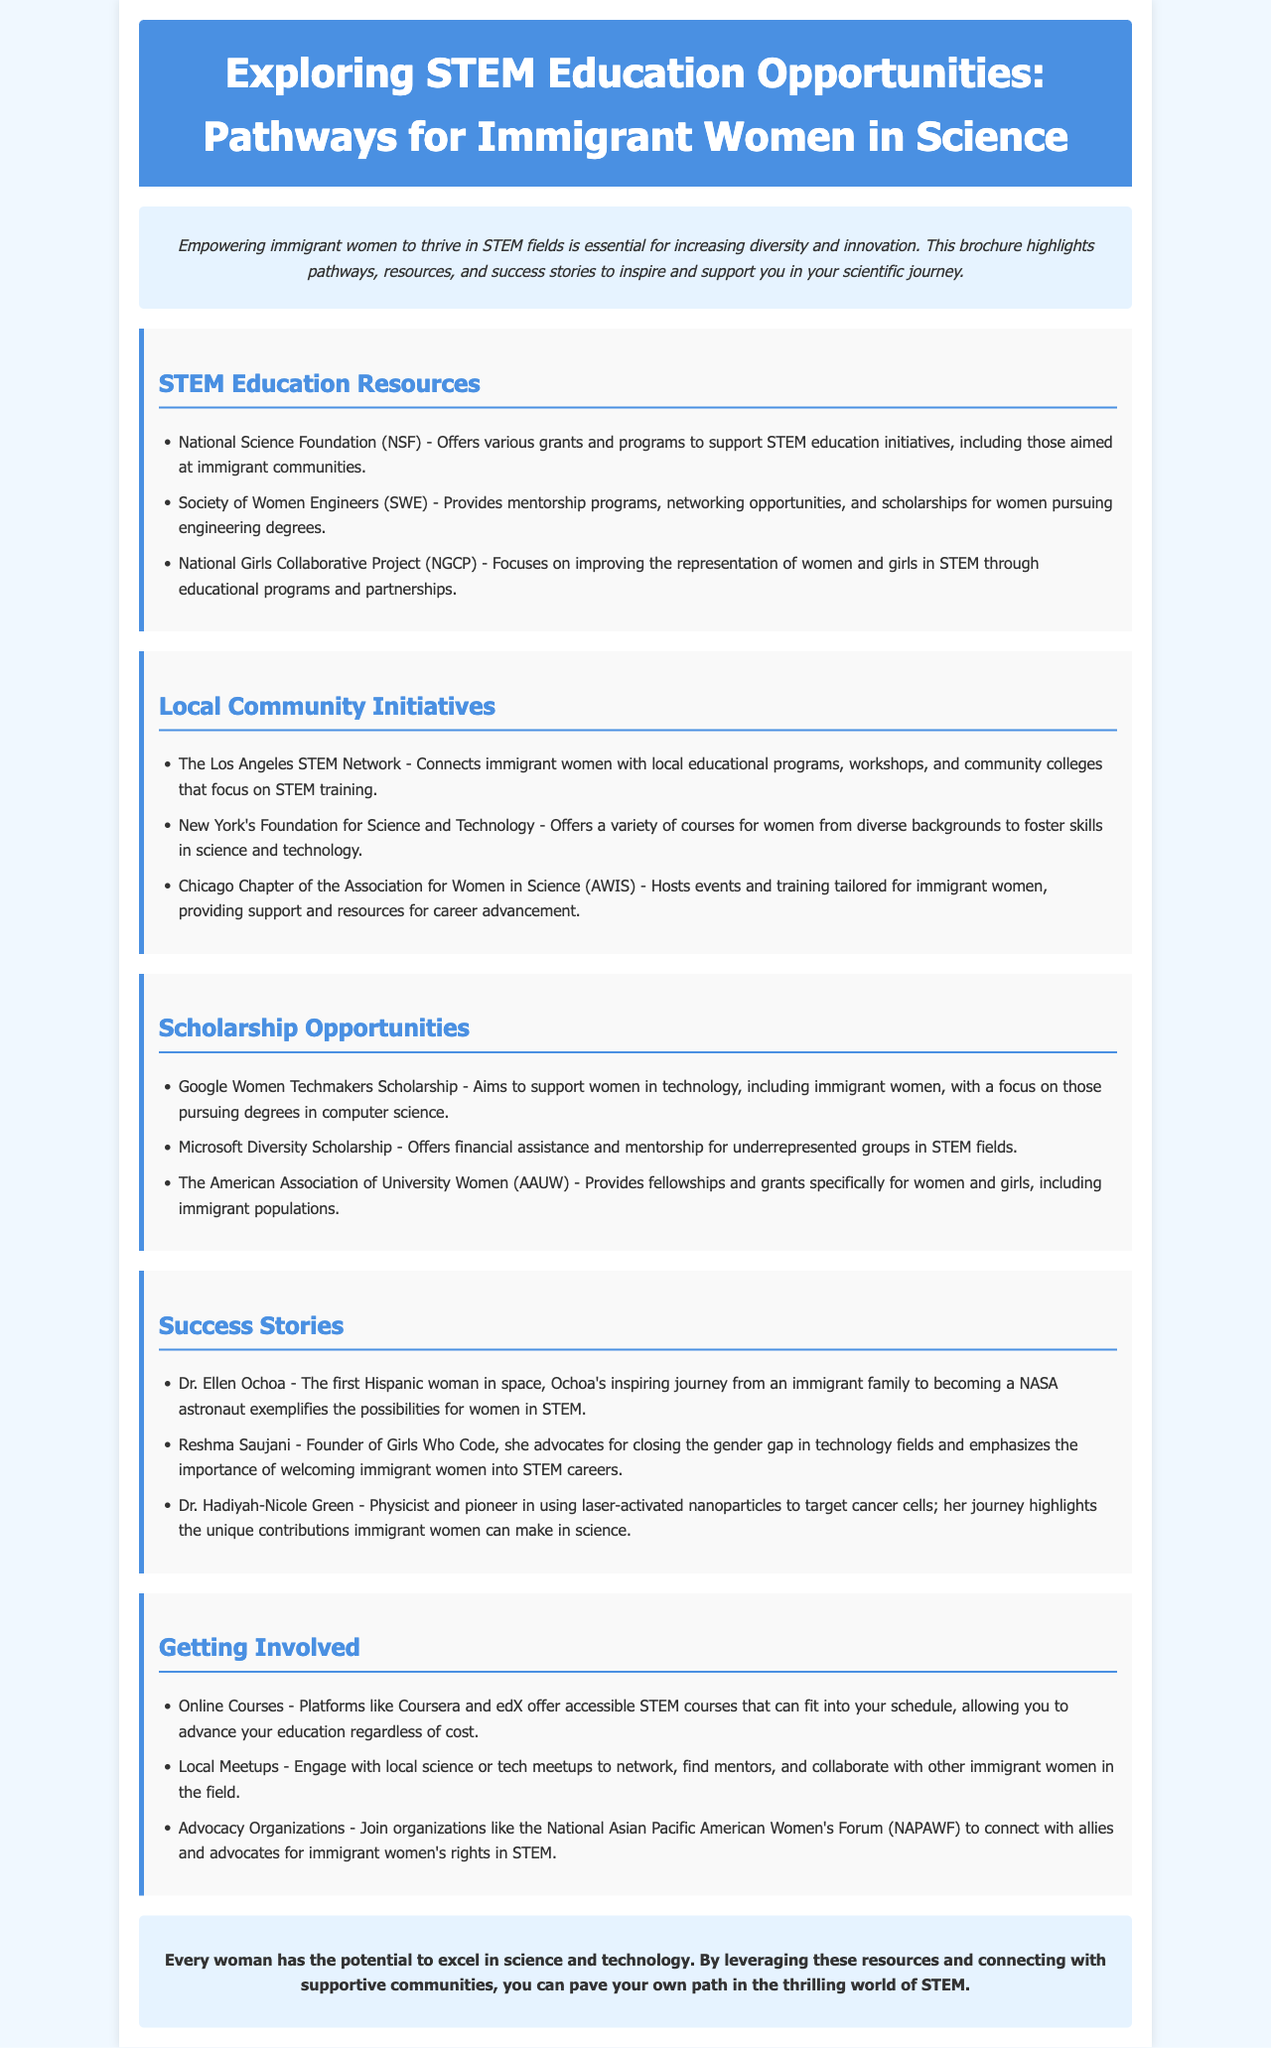What is the title of the brochure? The title is mentioned at the top of the document, clearly stating the focus of the content.
Answer: Exploring STEM Education Opportunities: Pathways for Immigrant Women in Science What organization offers grants for STEM education initiatives? The document lists the National Science Foundation as a provider of grants for supporting STEM education.
Answer: National Science Foundation (NSF) Which city has a STEM network specifically for immigrant women? The brochure identifies the Los Angeles STEM Network as a community resource for immigrant women.
Answer: Los Angeles What scholarship program supports women pursuing degrees in computer science? The brochure includes the Google Women Techmakers Scholarship as a specific program aimed at supporting women in technology.
Answer: Google Women Techmakers Scholarship Who is the founder of Girls Who Code? The document cites Reshma Saujani as the founder and advocate for immigrant women in STEM fields.
Answer: Reshma Saujani What type of courses do platforms like Coursera and edX offer? The brochure mentions that these platforms provide accessible STEM courses for education advancement.
Answer: Online Courses How many key success stories are listed in the brochure? The document includes three notable success stories of women in STEM as inspiring examples.
Answer: Three What is the emphasis of the National Girls Collaborative Project? This initiative focuses on improving representation of women and girls in STEM.
Answer: Improving representation of women and girls in STEM What color is the background of the introduction section? The introduction section features a light blue background color that distinguishes it from other sections.
Answer: Light blue 